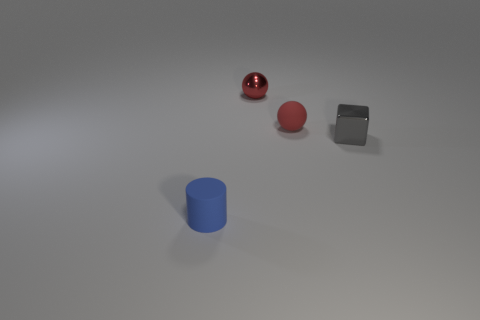There is a block that is the same size as the cylinder; what is it made of?
Provide a succinct answer. Metal. What number of small things are either gray things or rubber balls?
Ensure brevity in your answer.  2. Does the tiny gray metallic object have the same shape as the tiny blue thing?
Provide a short and direct response. No. How many matte objects are both in front of the gray metallic cube and behind the gray block?
Give a very brief answer. 0. Are there any other things that are the same color as the small metallic ball?
Your answer should be compact. Yes. What is the shape of the other tiny thing that is made of the same material as the blue object?
Provide a succinct answer. Sphere. Do the red shiny thing and the red matte sphere have the same size?
Provide a succinct answer. Yes. Is the material of the tiny thing in front of the tiny metal cube the same as the gray cube?
Offer a very short reply. No. Is there anything else that is made of the same material as the small blue cylinder?
Your answer should be very brief. Yes. What number of red balls are on the right side of the sphere that is left of the rubber object that is right of the blue object?
Make the answer very short. 1. 